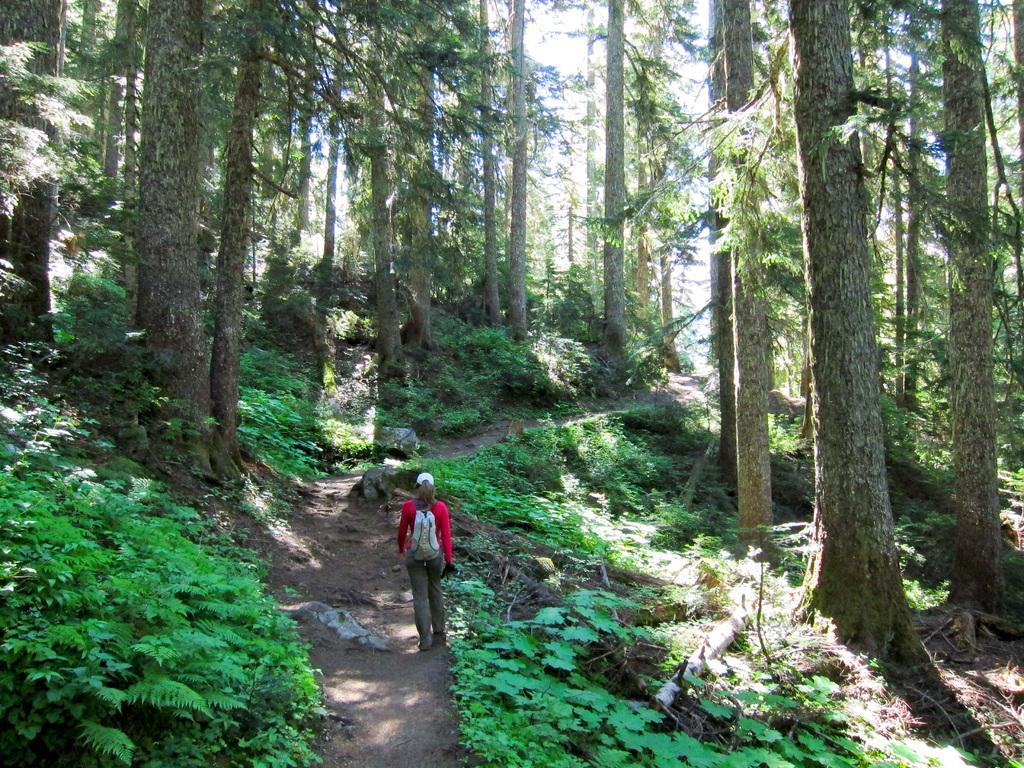What is the main subject of the image? There is a person on the ground in the image. What type of vegetation can be seen in the image? There are plants in the image. What can be seen in the background of the image? There are trees and the sky visible in the background of the image. What type of team is visible in the image? There is no team present in the image; it features a person on the ground, plants, trees, and the sky. What type of structure can be seen in the image? There is no structure present in the image; it features a person on the ground, plants, trees, and the sky. 